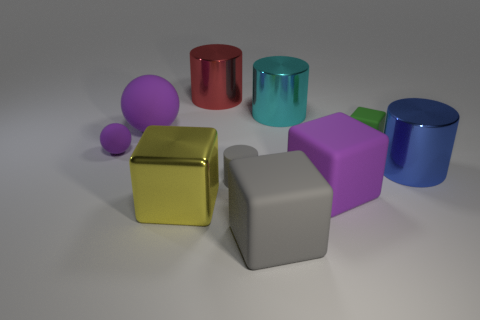Does the large metallic cylinder that is in front of the cyan metal cylinder have the same color as the matte cylinder?
Provide a short and direct response. No. What is the size of the object that is behind the tiny matte sphere and on the left side of the yellow metallic thing?
Your answer should be very brief. Large. How many big things are green blocks or gray objects?
Keep it short and to the point. 1. What is the shape of the green object that is in front of the big cyan thing?
Offer a terse response. Cube. What number of large things are there?
Make the answer very short. 7. Are the big blue cylinder and the cyan object made of the same material?
Provide a succinct answer. Yes. Are there more purple rubber things behind the blue metallic cylinder than small red metallic things?
Offer a very short reply. Yes. How many things are gray matte blocks or cylinders behind the cyan thing?
Your response must be concise. 2. Is the number of big gray cubes on the left side of the large sphere greater than the number of matte things right of the purple block?
Keep it short and to the point. No. There is a purple thing that is to the right of the big metal object in front of the large purple object that is in front of the gray matte cylinder; what is it made of?
Provide a succinct answer. Rubber. 